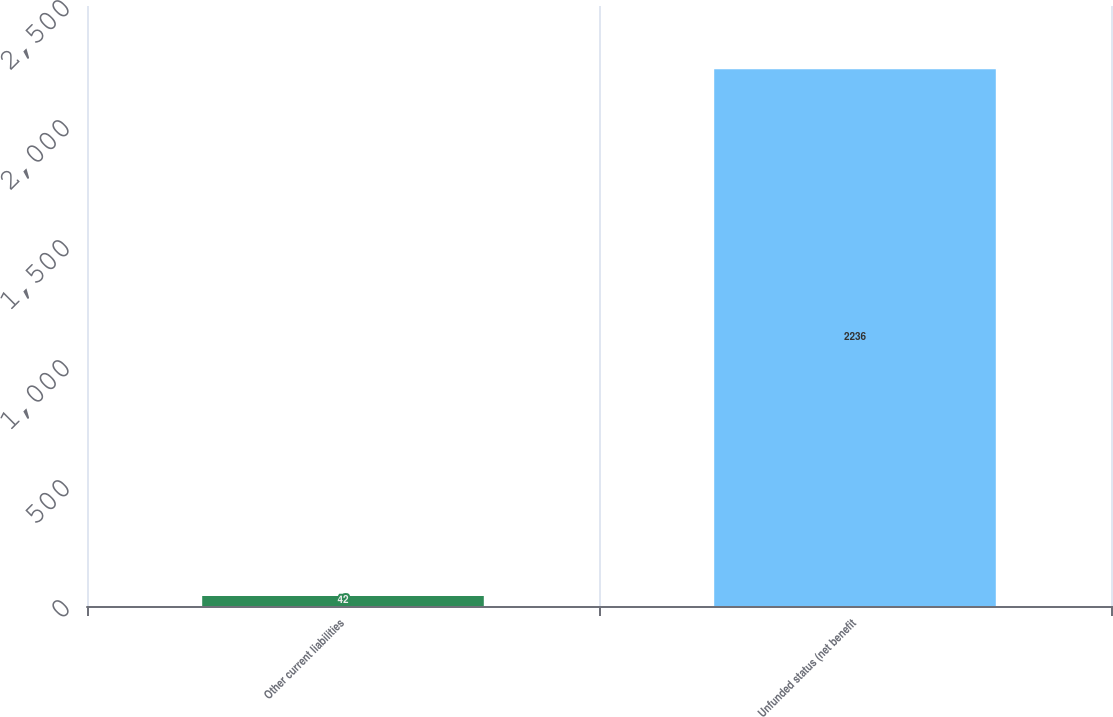Convert chart to OTSL. <chart><loc_0><loc_0><loc_500><loc_500><bar_chart><fcel>Other current liabilities<fcel>Unfunded status (net benefit<nl><fcel>42<fcel>2236<nl></chart> 